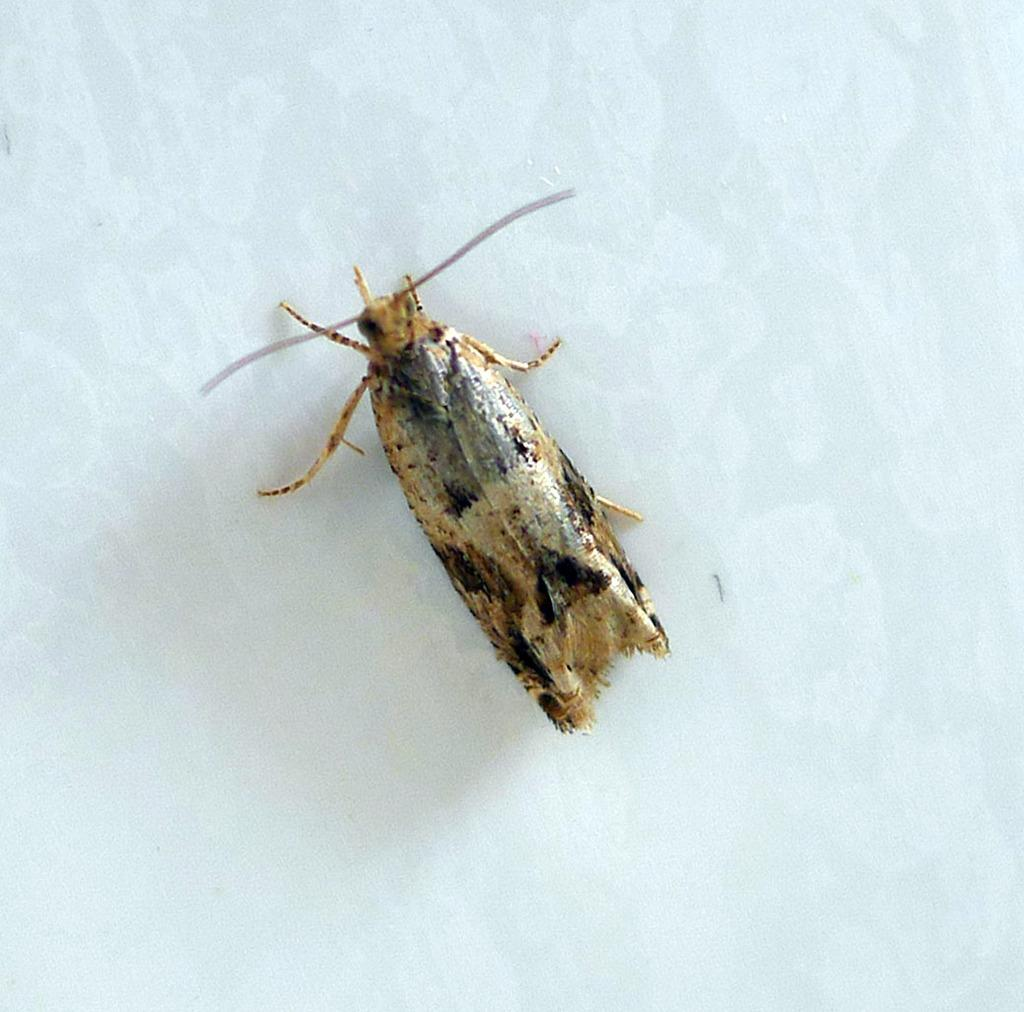What type of creature can be seen in the image? There is an insect in the image. What color is the background of the image? The background of the image is white. What type of teeth can be seen in the image? There are no teeth present in the image; it features an insect on a white background. What type of curtain is hanging in the image? There is no curtain present in the image; it features an insect on a white background. 